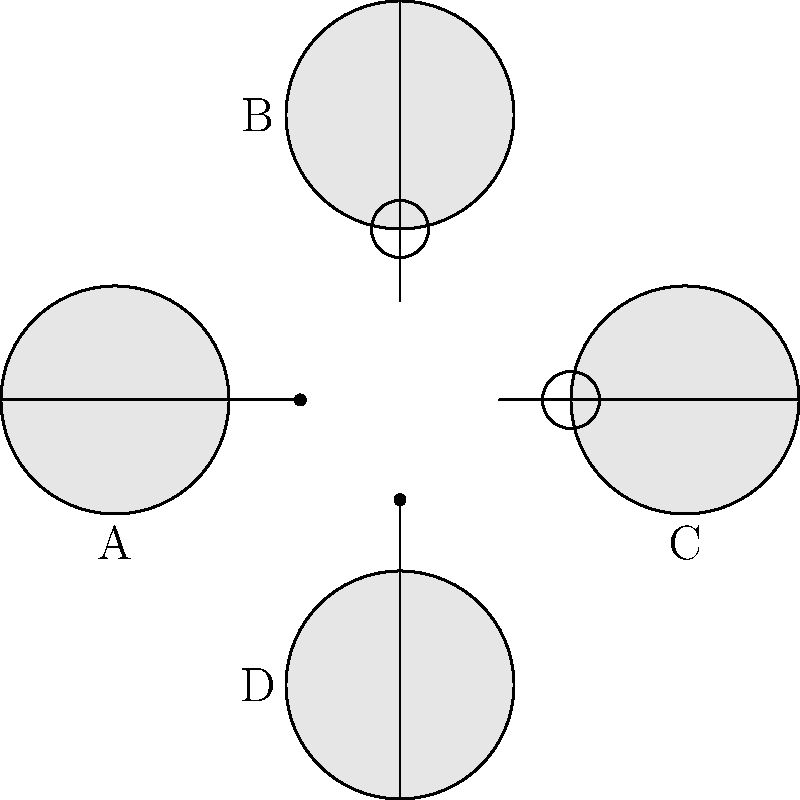Which pair of spacecraft in the diagram represents a compatible docking configuration for successful coupling in space? To determine the compatible docking configuration, we need to analyze the docking mechanisms shown in the diagram:

1. Spacecraft docking mechanisms typically consist of two complementary parts: a probe and a drogue.
2. The probe is an extending rod with a capture latch at the end.
3. The drogue is a cone-shaped receptacle that guides and receives the probe.
4. For successful docking, one spacecraft must have a probe, and the other must have a drogue.

Examining the diagram:
- Spacecraft A has a probe extending to the right.
- Spacecraft B has a drogue facing downward.
- Spacecraft C has a drogue facing to the left.
- Spacecraft D has a probe extending upward.

For a compatible configuration:
- The probe of one spacecraft must align with the drogue of another.
- The spacecraft must be oriented correctly for the mechanisms to engage.

Looking at the possible combinations:
- A and B are not compatible due to misalignment.
- A and C form a compatible pair, with A's probe aligning with C's drogue.
- A and D are not compatible as both have probes.
- B and C are not compatible as both have drogues.
- B and D form a compatible pair, with D's probe aligning with B's drogue.

Therefore, there are two compatible pairs: A-C and B-D. However, the question asks for a single pair, and the most obvious alignment in the diagram is between A and C.
Answer: A and C 